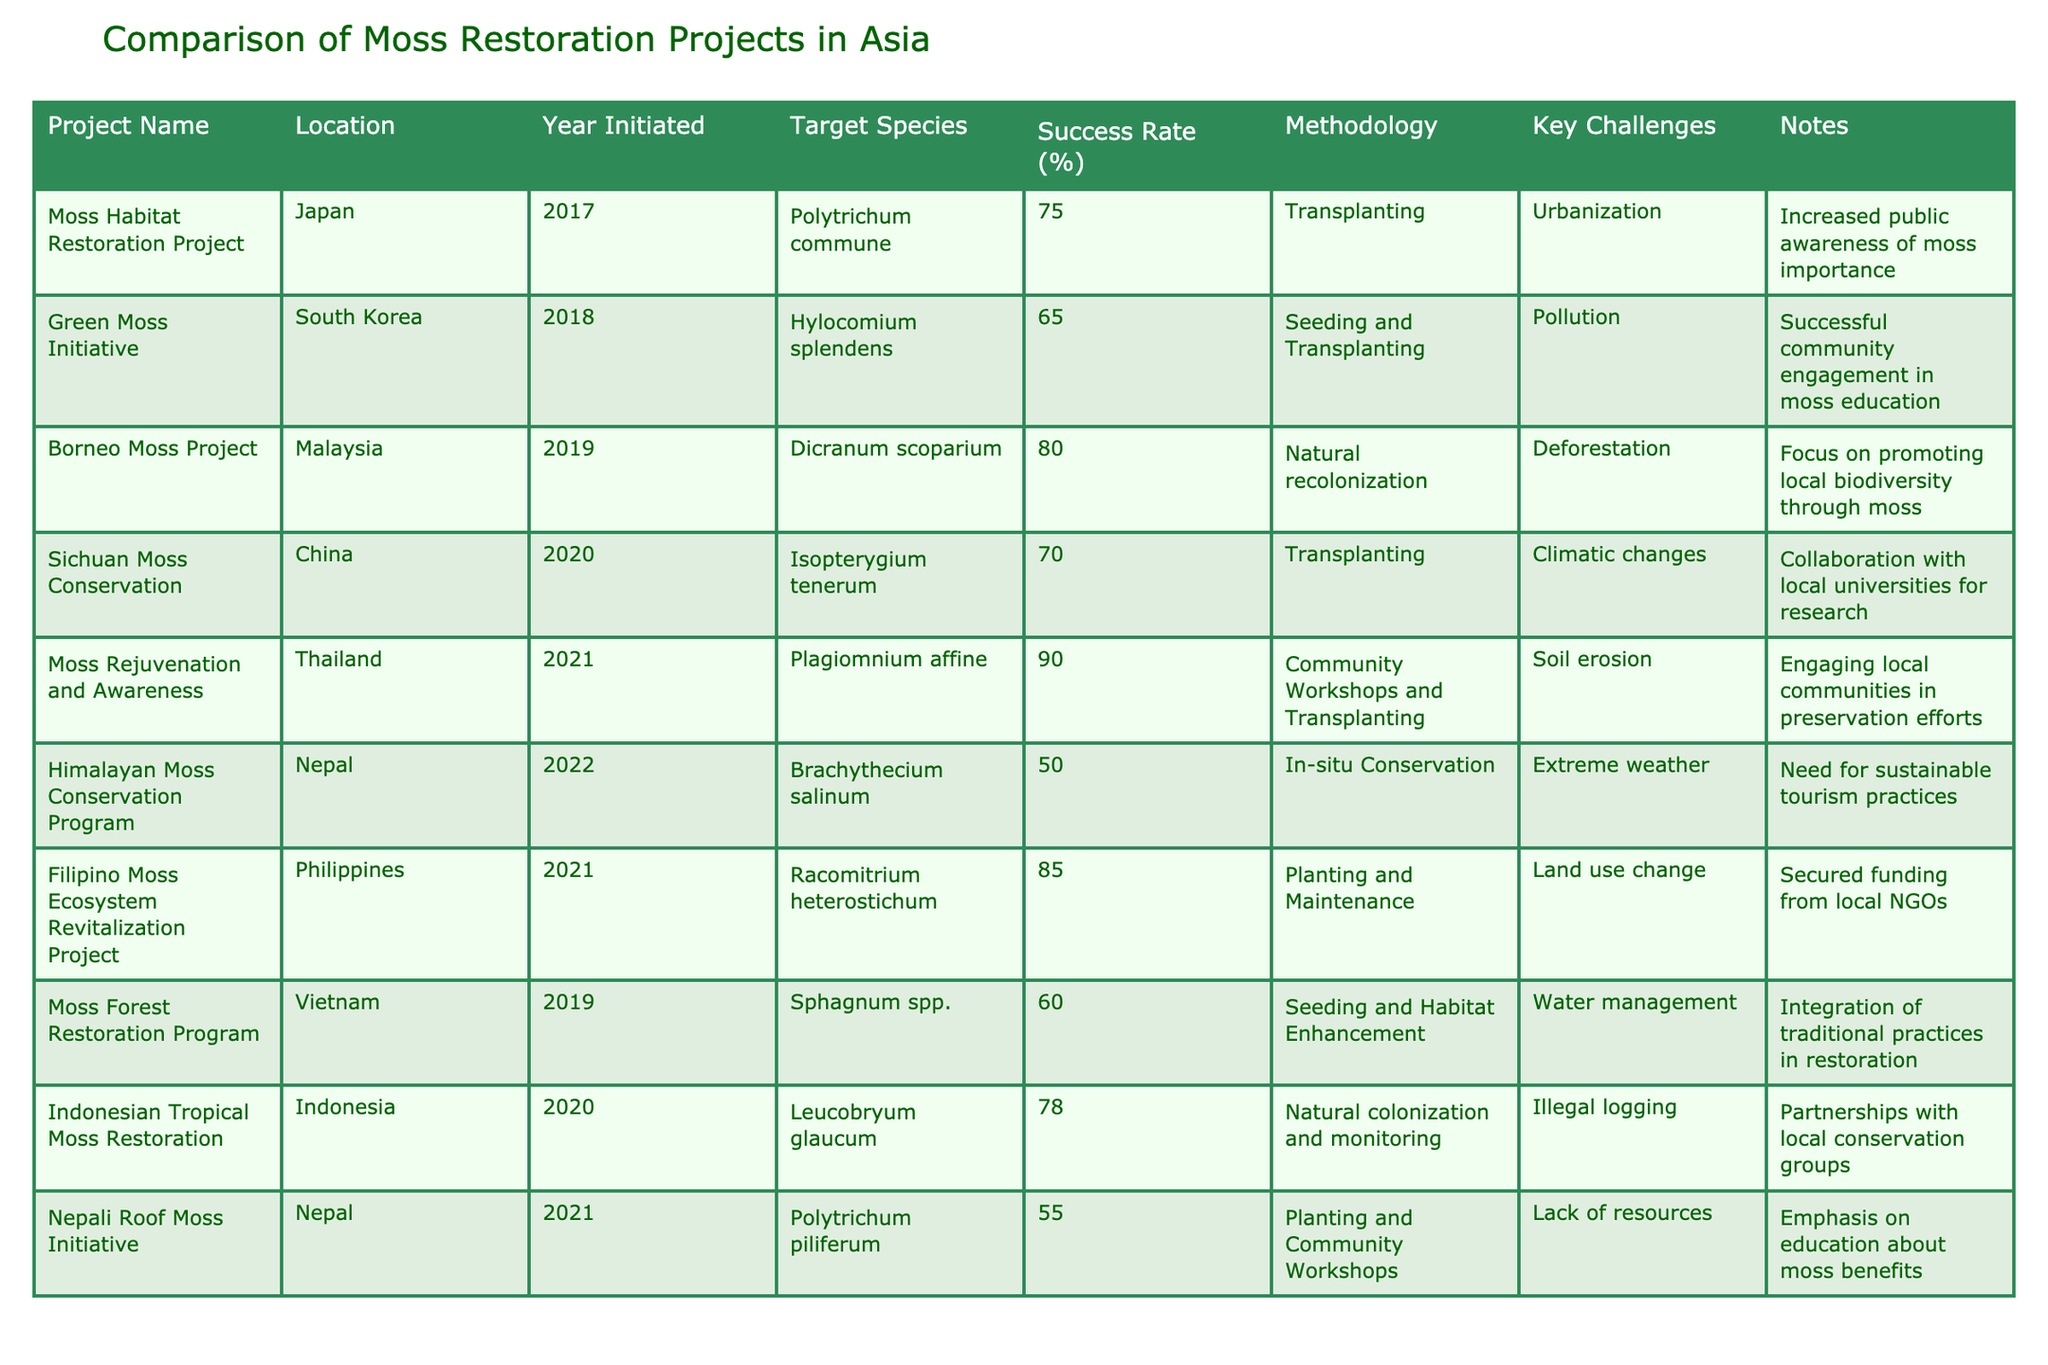What is the success rate of the Moss Rejuvenation and Awareness project in Thailand? The table entry for the Moss Rejuvenation and Awareness project in Thailand indicates a success rate of 90%.
Answer: 90% Which project initiated in 2019 has the highest success rate? The Borneo Moss Project, initiated in 2019, has the highest success rate of 80%.
Answer: Borneo Moss Project Is the success rate of restoring Racomitrium heterostichum in the Philippines higher or lower than 80%? The success rate for Racomitrium heterostichum in the Philippines is 85%, which is higher than 80%.
Answer: Higher What is the average success rate of all projects that involved transplanting methodology? The projects utilizing transplanting methodology have success rates of 75% (Japan), 70% (China), 90% (Thailand), and 55% (Nepal). Adding these rates gives 75 + 70 + 90 + 55 = 290, and dividing by 4 (the number of projects) results in an average of 290/4 = 72.5%.
Answer: 72.5% Which country has the lowest success rate in moss restoration projects based on this table? The Himalayan Moss Conservation Program in Nepal has the lowest success rate of 50%.
Answer: Nepal Of the projects listed, how many have community engagement as part of their methodology? The Moss Rejuvenation and Awareness (Thailand) and Nepali Roof Moss Initiative (Nepal) both include community engagement methods. Therefore, there are 2 projects with community engagement.
Answer: 2 What are the key challenges faced by the Sphagnum spp. restoration project in Vietnam? The key challenge for the Sphagnum spp. restoration project outlined in the table is water management.
Answer: Water management Which project or projects involve funding or support from local NGOs? The Filipino Moss Ecosystem Revitalization Project includes secured funding from local NGOs.
Answer: Filipino Moss Ecosystem Revitalization Project How do the success rates of projects in Nepal compare with those in South Korea? The success rates for projects in Nepal are 50% (Himalayan Moss Conservation Program) and 55% (Nepali Roof Moss Initiative), and for South Korea, the success rate is 65% (Green Moss Initiative). Both projects in Nepal average 52.5%, which is lower than South Korea's 65%.
Answer: Lower Is there any project that reports climate changes as a key challenge? Yes, the Sichuan Moss Conservation project in China lists climatic changes as a key challenge.
Answer: Yes 